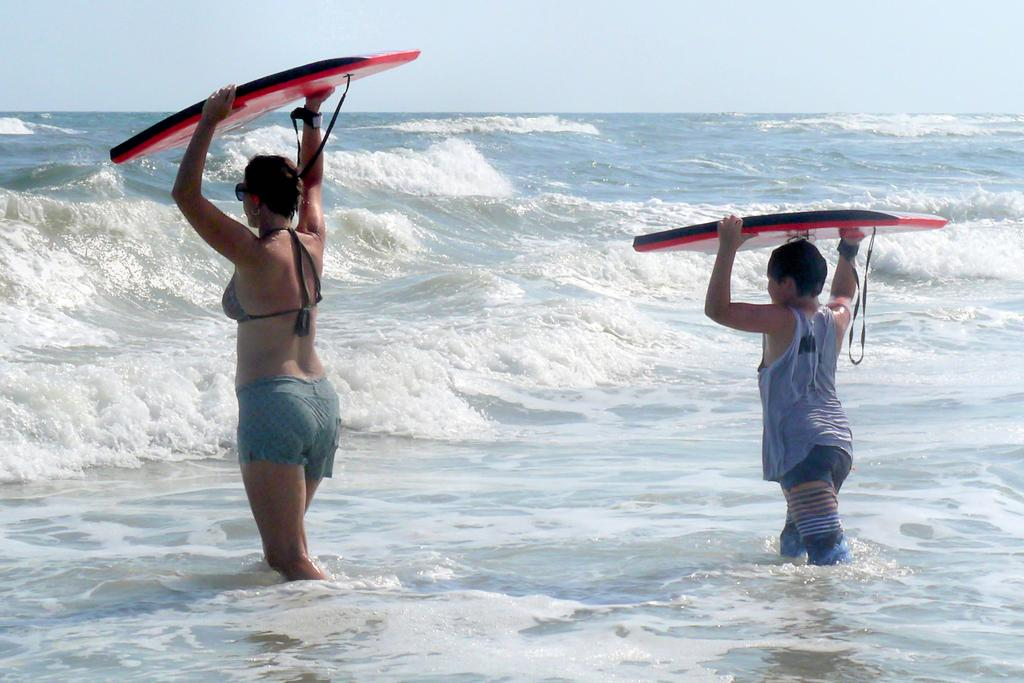Who are the people in the image? There is a woman and a boy in the image. What is the boy holding in the image? The boy is holding a surfing board. What can be seen in the background of the image? There is water visible in the image. What statement is the woman making to the children in the image? There are no children present in the image, and the woman is not making any statements. 